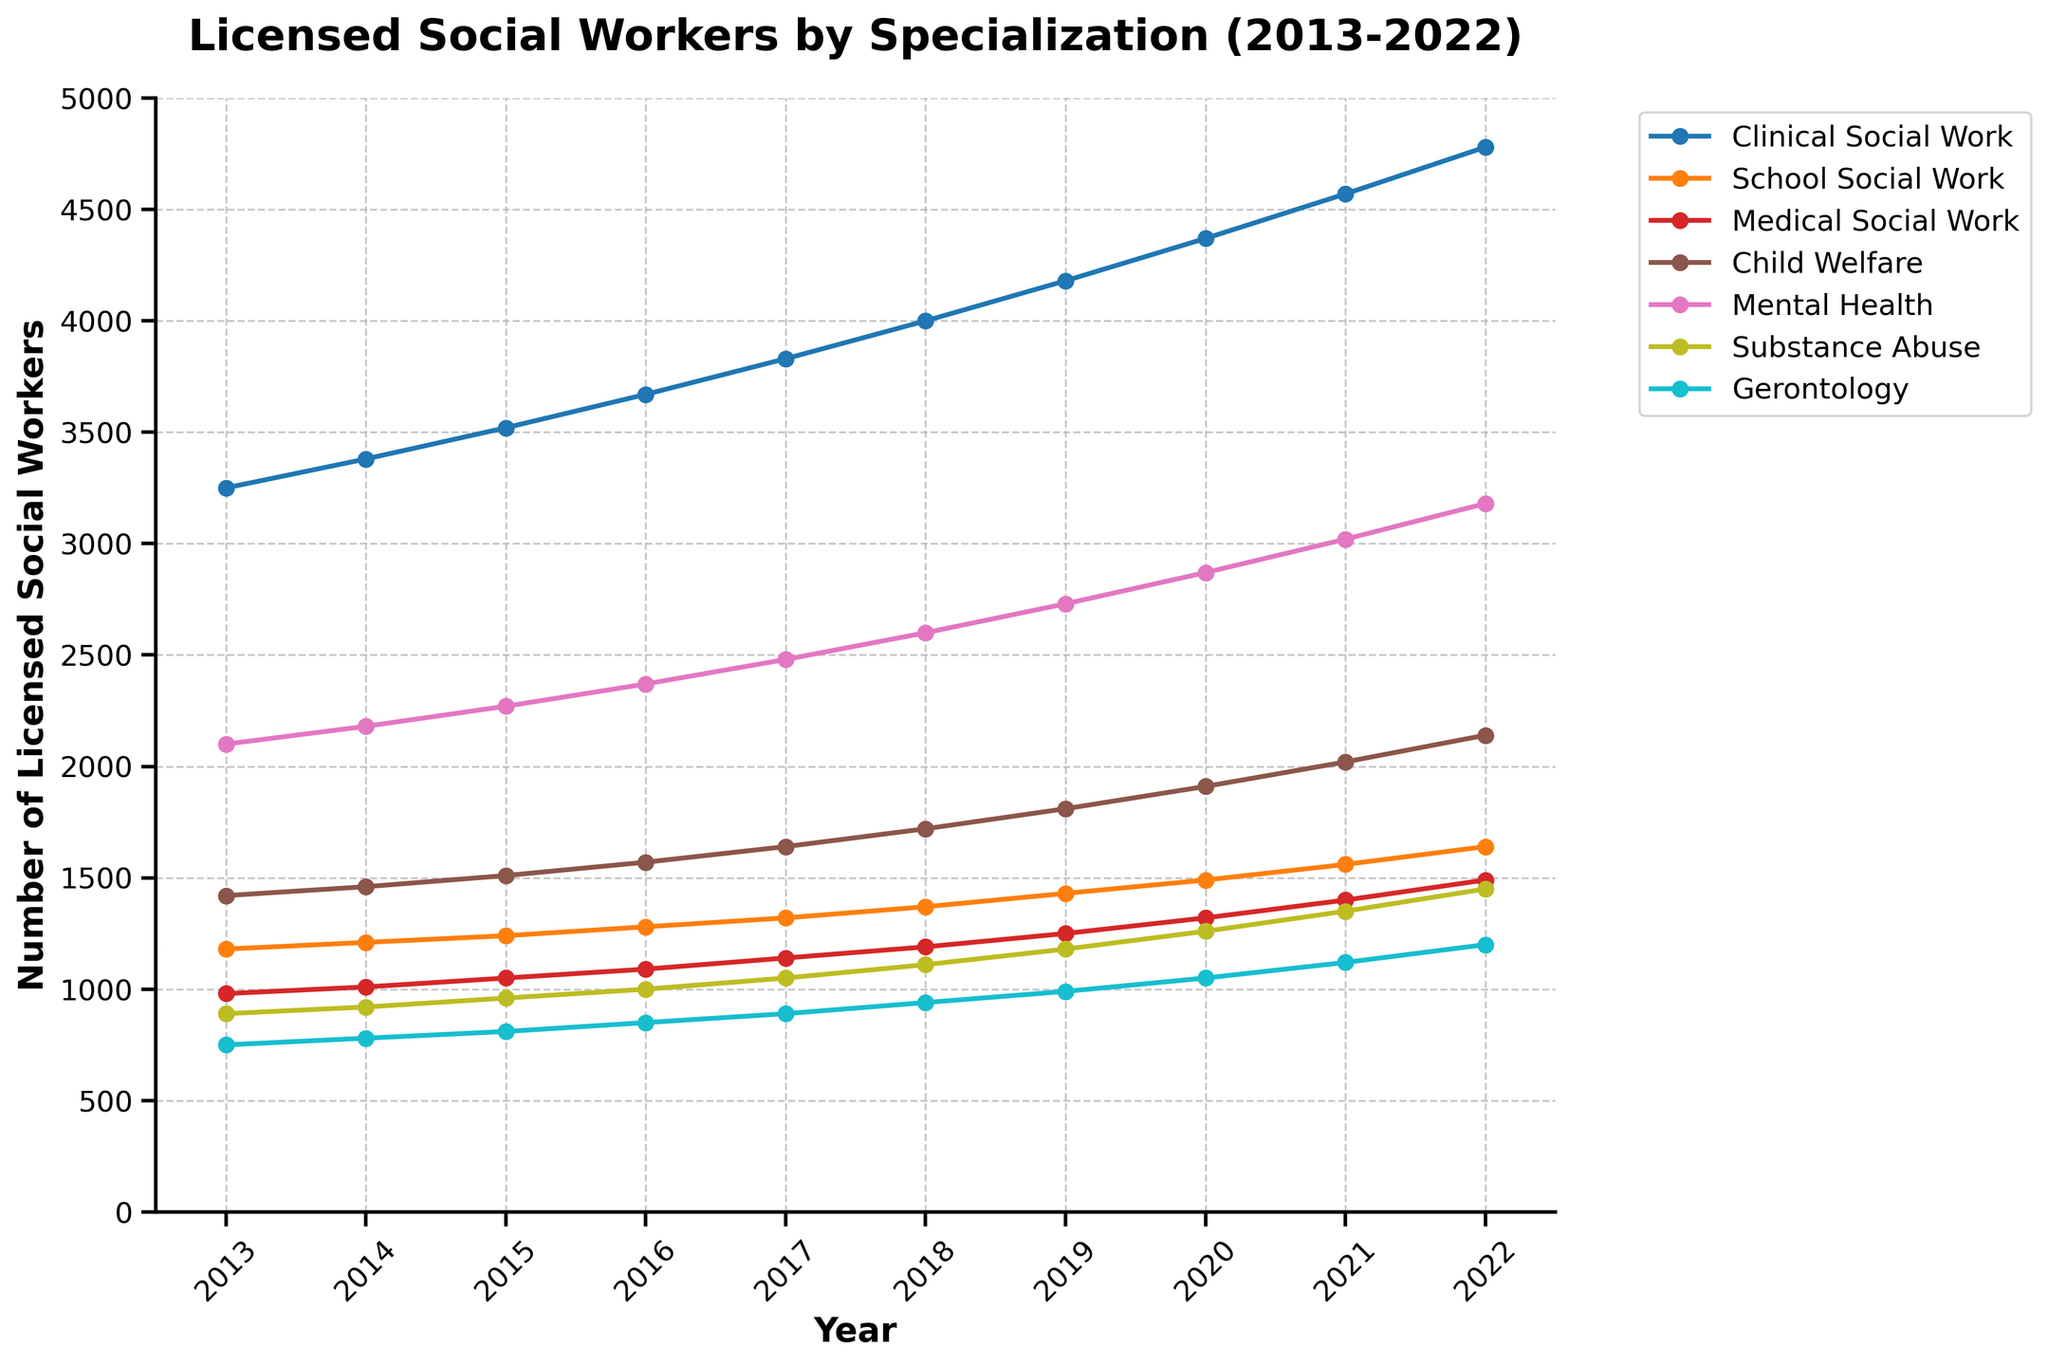What's the total number of licensed social workers across all specializations in 2022? To find the total number, sum the values of licensed social workers in all specializations for the year 2022. The values are: 4780 (Clinical Social Work) + 1640 (School Social Work) + 1490 (Medical Social Work) + 2140 (Child Welfare) + 3180 (Mental Health) + 1450 (Substance Abuse) + 1200 (Gerontology). This amounts to 4780 + 1640 + 1490 + 2140 + 3180 + 1450 + 1200 = 15880.
Answer: 15880 Which specialization has the highest number of licensed social workers in 2022? Identify the specialization with the highest data point for the year 2022 by comparing all values for that year. The highest value is 4780 (Clinical Social Work).
Answer: Clinical Social Work In which year did Child Welfare first surpass 2000 licensed social workers? Look at the trend line for Child Welfare and find the first year where the number of social workers is greater than 2000. This happens in the year 2021 with 2020 licensed social workers.
Answer: 2021 What is the percentage increase in Clinical Social Work from 2013 to 2022? Calculate the percentage increase using the formula: ((value in 2022 - value in 2013) / value in 2013) * 100%. For Clinical Social Work, the values are 3250 in 2013 and 4780 in 2022. The increase is (4780 - 3250) / 3250 * 100% = 47.08%.
Answer: 47.08% Which specialization showed the least growth in the number of licensed social workers from 2013 to 2022? Compare the growth rates of all specializations from 2013 to 2022 by checking the differences between the values in 2022 and 2013. Gerontology increased from 750 to 1200, a growth of 450. This is the smallest growth among all specializations.
Answer: Gerontology Did any specialization experience a decline at any point between 2013 and 2022? Check each specialization's trend line for any dips indicating a decrease in the number of social workers. None of the lines show a decline; all specializations show consistent growth.
Answer: No By how many did School Social Work increase from 2018 to 2020? Subtract the number of School Social Workers in 2018 from the number in 2020. The values are 1490 in 2020 and 1370 in 2018, so the increase is 1490 - 1370 = 120.
Answer: 120 Which year had the highest overall number of social workers for all specializations combined? Calculate the sum for each year and compare them. The highest sum is in 2022 with 15880 total social workers.
Answer: 2022 